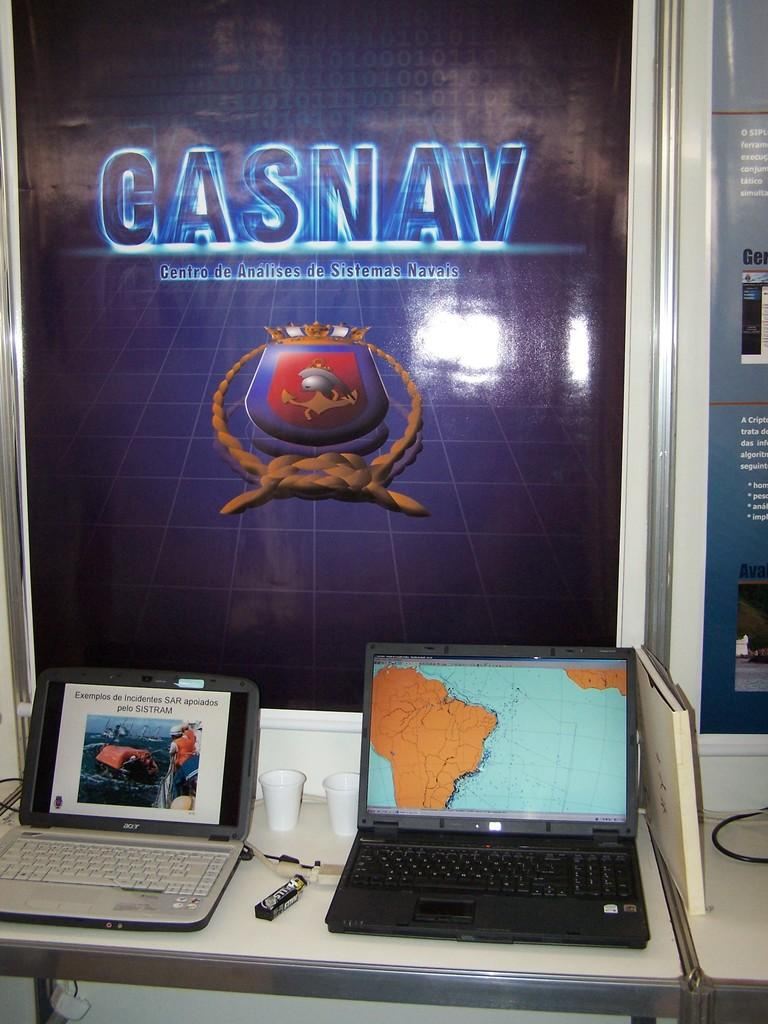<image>
Summarize the visual content of the image. A poster has the word Casnav printed across the top. 